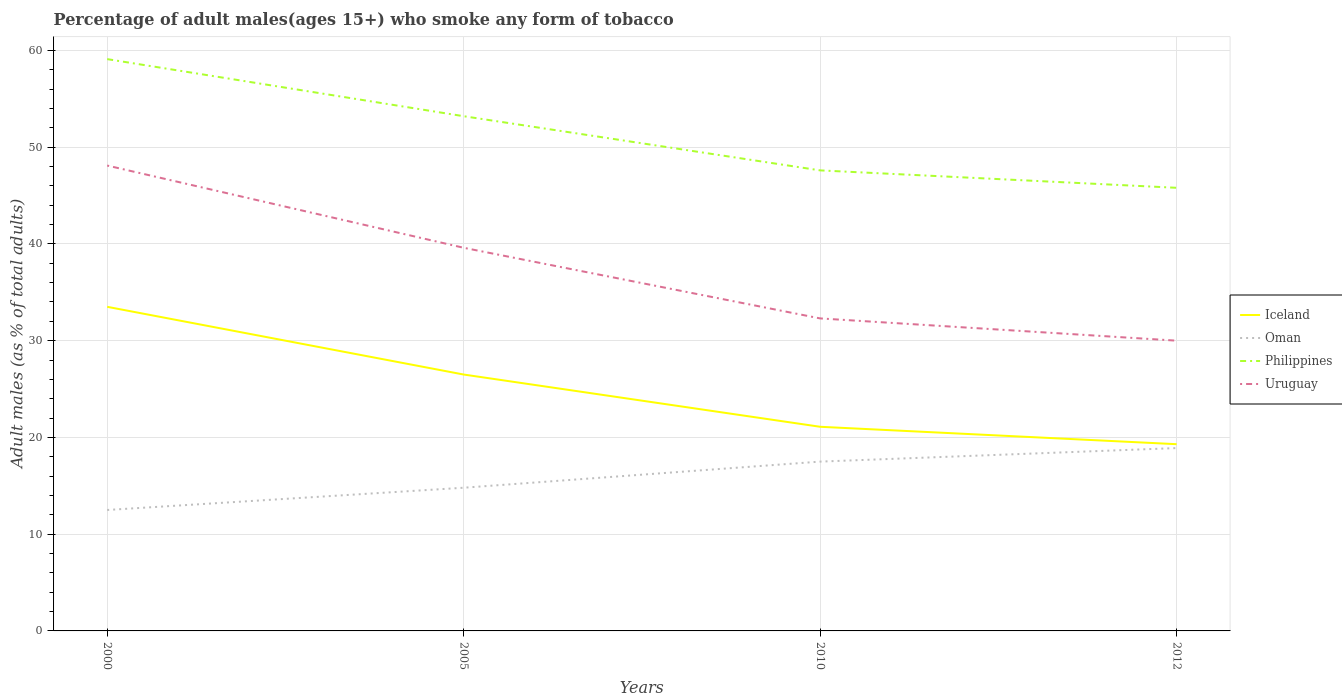How many different coloured lines are there?
Offer a very short reply. 4. Does the line corresponding to Philippines intersect with the line corresponding to Iceland?
Give a very brief answer. No. Is the number of lines equal to the number of legend labels?
Provide a short and direct response. Yes. Across all years, what is the maximum percentage of adult males who smoke in Iceland?
Offer a very short reply. 19.3. In which year was the percentage of adult males who smoke in Iceland maximum?
Offer a very short reply. 2012. What is the total percentage of adult males who smoke in Oman in the graph?
Provide a short and direct response. -5. What is the difference between the highest and the lowest percentage of adult males who smoke in Philippines?
Keep it short and to the point. 2. Is the percentage of adult males who smoke in Uruguay strictly greater than the percentage of adult males who smoke in Philippines over the years?
Your answer should be very brief. Yes. Does the graph contain any zero values?
Offer a very short reply. No. Where does the legend appear in the graph?
Your response must be concise. Center right. How many legend labels are there?
Your response must be concise. 4. How are the legend labels stacked?
Offer a terse response. Vertical. What is the title of the graph?
Give a very brief answer. Percentage of adult males(ages 15+) who smoke any form of tobacco. What is the label or title of the X-axis?
Provide a short and direct response. Years. What is the label or title of the Y-axis?
Keep it short and to the point. Adult males (as % of total adults). What is the Adult males (as % of total adults) of Iceland in 2000?
Your answer should be compact. 33.5. What is the Adult males (as % of total adults) in Philippines in 2000?
Provide a short and direct response. 59.1. What is the Adult males (as % of total adults) in Uruguay in 2000?
Give a very brief answer. 48.1. What is the Adult males (as % of total adults) of Iceland in 2005?
Provide a succinct answer. 26.5. What is the Adult males (as % of total adults) of Oman in 2005?
Your answer should be compact. 14.8. What is the Adult males (as % of total adults) in Philippines in 2005?
Give a very brief answer. 53.2. What is the Adult males (as % of total adults) in Uruguay in 2005?
Your answer should be very brief. 39.6. What is the Adult males (as % of total adults) in Iceland in 2010?
Offer a terse response. 21.1. What is the Adult males (as % of total adults) of Philippines in 2010?
Make the answer very short. 47.6. What is the Adult males (as % of total adults) of Uruguay in 2010?
Offer a terse response. 32.3. What is the Adult males (as % of total adults) of Iceland in 2012?
Provide a succinct answer. 19.3. What is the Adult males (as % of total adults) of Oman in 2012?
Your response must be concise. 18.9. What is the Adult males (as % of total adults) of Philippines in 2012?
Your answer should be compact. 45.8. Across all years, what is the maximum Adult males (as % of total adults) of Iceland?
Your answer should be very brief. 33.5. Across all years, what is the maximum Adult males (as % of total adults) of Oman?
Offer a very short reply. 18.9. Across all years, what is the maximum Adult males (as % of total adults) of Philippines?
Your response must be concise. 59.1. Across all years, what is the maximum Adult males (as % of total adults) in Uruguay?
Your answer should be very brief. 48.1. Across all years, what is the minimum Adult males (as % of total adults) of Iceland?
Your answer should be very brief. 19.3. Across all years, what is the minimum Adult males (as % of total adults) in Philippines?
Your answer should be compact. 45.8. What is the total Adult males (as % of total adults) in Iceland in the graph?
Your answer should be very brief. 100.4. What is the total Adult males (as % of total adults) in Oman in the graph?
Make the answer very short. 63.7. What is the total Adult males (as % of total adults) of Philippines in the graph?
Provide a short and direct response. 205.7. What is the total Adult males (as % of total adults) in Uruguay in the graph?
Provide a succinct answer. 150. What is the difference between the Adult males (as % of total adults) in Iceland in 2000 and that in 2005?
Your response must be concise. 7. What is the difference between the Adult males (as % of total adults) in Philippines in 2000 and that in 2005?
Ensure brevity in your answer.  5.9. What is the difference between the Adult males (as % of total adults) in Uruguay in 2000 and that in 2005?
Give a very brief answer. 8.5. What is the difference between the Adult males (as % of total adults) in Iceland in 2000 and that in 2010?
Your answer should be compact. 12.4. What is the difference between the Adult males (as % of total adults) of Philippines in 2000 and that in 2010?
Make the answer very short. 11.5. What is the difference between the Adult males (as % of total adults) of Oman in 2000 and that in 2012?
Provide a short and direct response. -6.4. What is the difference between the Adult males (as % of total adults) in Iceland in 2005 and that in 2010?
Keep it short and to the point. 5.4. What is the difference between the Adult males (as % of total adults) of Uruguay in 2005 and that in 2010?
Your answer should be very brief. 7.3. What is the difference between the Adult males (as % of total adults) in Philippines in 2005 and that in 2012?
Your answer should be compact. 7.4. What is the difference between the Adult males (as % of total adults) in Iceland in 2010 and that in 2012?
Provide a short and direct response. 1.8. What is the difference between the Adult males (as % of total adults) of Iceland in 2000 and the Adult males (as % of total adults) of Philippines in 2005?
Provide a short and direct response. -19.7. What is the difference between the Adult males (as % of total adults) in Iceland in 2000 and the Adult males (as % of total adults) in Uruguay in 2005?
Provide a succinct answer. -6.1. What is the difference between the Adult males (as % of total adults) of Oman in 2000 and the Adult males (as % of total adults) of Philippines in 2005?
Provide a short and direct response. -40.7. What is the difference between the Adult males (as % of total adults) in Oman in 2000 and the Adult males (as % of total adults) in Uruguay in 2005?
Provide a short and direct response. -27.1. What is the difference between the Adult males (as % of total adults) in Philippines in 2000 and the Adult males (as % of total adults) in Uruguay in 2005?
Provide a short and direct response. 19.5. What is the difference between the Adult males (as % of total adults) in Iceland in 2000 and the Adult males (as % of total adults) in Philippines in 2010?
Provide a succinct answer. -14.1. What is the difference between the Adult males (as % of total adults) in Oman in 2000 and the Adult males (as % of total adults) in Philippines in 2010?
Provide a short and direct response. -35.1. What is the difference between the Adult males (as % of total adults) of Oman in 2000 and the Adult males (as % of total adults) of Uruguay in 2010?
Your answer should be very brief. -19.8. What is the difference between the Adult males (as % of total adults) of Philippines in 2000 and the Adult males (as % of total adults) of Uruguay in 2010?
Keep it short and to the point. 26.8. What is the difference between the Adult males (as % of total adults) in Iceland in 2000 and the Adult males (as % of total adults) in Oman in 2012?
Make the answer very short. 14.6. What is the difference between the Adult males (as % of total adults) of Iceland in 2000 and the Adult males (as % of total adults) of Philippines in 2012?
Offer a very short reply. -12.3. What is the difference between the Adult males (as % of total adults) in Oman in 2000 and the Adult males (as % of total adults) in Philippines in 2012?
Your answer should be compact. -33.3. What is the difference between the Adult males (as % of total adults) of Oman in 2000 and the Adult males (as % of total adults) of Uruguay in 2012?
Make the answer very short. -17.5. What is the difference between the Adult males (as % of total adults) of Philippines in 2000 and the Adult males (as % of total adults) of Uruguay in 2012?
Offer a very short reply. 29.1. What is the difference between the Adult males (as % of total adults) in Iceland in 2005 and the Adult males (as % of total adults) in Oman in 2010?
Your response must be concise. 9. What is the difference between the Adult males (as % of total adults) of Iceland in 2005 and the Adult males (as % of total adults) of Philippines in 2010?
Offer a terse response. -21.1. What is the difference between the Adult males (as % of total adults) of Oman in 2005 and the Adult males (as % of total adults) of Philippines in 2010?
Make the answer very short. -32.8. What is the difference between the Adult males (as % of total adults) of Oman in 2005 and the Adult males (as % of total adults) of Uruguay in 2010?
Give a very brief answer. -17.5. What is the difference between the Adult males (as % of total adults) of Philippines in 2005 and the Adult males (as % of total adults) of Uruguay in 2010?
Offer a terse response. 20.9. What is the difference between the Adult males (as % of total adults) of Iceland in 2005 and the Adult males (as % of total adults) of Oman in 2012?
Give a very brief answer. 7.6. What is the difference between the Adult males (as % of total adults) of Iceland in 2005 and the Adult males (as % of total adults) of Philippines in 2012?
Provide a short and direct response. -19.3. What is the difference between the Adult males (as % of total adults) of Oman in 2005 and the Adult males (as % of total adults) of Philippines in 2012?
Provide a succinct answer. -31. What is the difference between the Adult males (as % of total adults) of Oman in 2005 and the Adult males (as % of total adults) of Uruguay in 2012?
Keep it short and to the point. -15.2. What is the difference between the Adult males (as % of total adults) of Philippines in 2005 and the Adult males (as % of total adults) of Uruguay in 2012?
Ensure brevity in your answer.  23.2. What is the difference between the Adult males (as % of total adults) in Iceland in 2010 and the Adult males (as % of total adults) in Philippines in 2012?
Provide a short and direct response. -24.7. What is the difference between the Adult males (as % of total adults) of Iceland in 2010 and the Adult males (as % of total adults) of Uruguay in 2012?
Make the answer very short. -8.9. What is the difference between the Adult males (as % of total adults) of Oman in 2010 and the Adult males (as % of total adults) of Philippines in 2012?
Your answer should be very brief. -28.3. What is the average Adult males (as % of total adults) of Iceland per year?
Provide a succinct answer. 25.1. What is the average Adult males (as % of total adults) of Oman per year?
Give a very brief answer. 15.93. What is the average Adult males (as % of total adults) of Philippines per year?
Provide a succinct answer. 51.42. What is the average Adult males (as % of total adults) of Uruguay per year?
Keep it short and to the point. 37.5. In the year 2000, what is the difference between the Adult males (as % of total adults) of Iceland and Adult males (as % of total adults) of Philippines?
Ensure brevity in your answer.  -25.6. In the year 2000, what is the difference between the Adult males (as % of total adults) of Iceland and Adult males (as % of total adults) of Uruguay?
Make the answer very short. -14.6. In the year 2000, what is the difference between the Adult males (as % of total adults) of Oman and Adult males (as % of total adults) of Philippines?
Your answer should be very brief. -46.6. In the year 2000, what is the difference between the Adult males (as % of total adults) of Oman and Adult males (as % of total adults) of Uruguay?
Offer a very short reply. -35.6. In the year 2000, what is the difference between the Adult males (as % of total adults) in Philippines and Adult males (as % of total adults) in Uruguay?
Your response must be concise. 11. In the year 2005, what is the difference between the Adult males (as % of total adults) in Iceland and Adult males (as % of total adults) in Oman?
Make the answer very short. 11.7. In the year 2005, what is the difference between the Adult males (as % of total adults) of Iceland and Adult males (as % of total adults) of Philippines?
Your answer should be compact. -26.7. In the year 2005, what is the difference between the Adult males (as % of total adults) of Oman and Adult males (as % of total adults) of Philippines?
Offer a very short reply. -38.4. In the year 2005, what is the difference between the Adult males (as % of total adults) in Oman and Adult males (as % of total adults) in Uruguay?
Make the answer very short. -24.8. In the year 2010, what is the difference between the Adult males (as % of total adults) in Iceland and Adult males (as % of total adults) in Philippines?
Offer a terse response. -26.5. In the year 2010, what is the difference between the Adult males (as % of total adults) of Iceland and Adult males (as % of total adults) of Uruguay?
Your answer should be very brief. -11.2. In the year 2010, what is the difference between the Adult males (as % of total adults) of Oman and Adult males (as % of total adults) of Philippines?
Keep it short and to the point. -30.1. In the year 2010, what is the difference between the Adult males (as % of total adults) of Oman and Adult males (as % of total adults) of Uruguay?
Provide a succinct answer. -14.8. In the year 2012, what is the difference between the Adult males (as % of total adults) of Iceland and Adult males (as % of total adults) of Philippines?
Give a very brief answer. -26.5. In the year 2012, what is the difference between the Adult males (as % of total adults) in Iceland and Adult males (as % of total adults) in Uruguay?
Provide a short and direct response. -10.7. In the year 2012, what is the difference between the Adult males (as % of total adults) in Oman and Adult males (as % of total adults) in Philippines?
Offer a very short reply. -26.9. In the year 2012, what is the difference between the Adult males (as % of total adults) of Oman and Adult males (as % of total adults) of Uruguay?
Offer a very short reply. -11.1. What is the ratio of the Adult males (as % of total adults) of Iceland in 2000 to that in 2005?
Your answer should be compact. 1.26. What is the ratio of the Adult males (as % of total adults) in Oman in 2000 to that in 2005?
Your answer should be very brief. 0.84. What is the ratio of the Adult males (as % of total adults) in Philippines in 2000 to that in 2005?
Offer a very short reply. 1.11. What is the ratio of the Adult males (as % of total adults) of Uruguay in 2000 to that in 2005?
Offer a very short reply. 1.21. What is the ratio of the Adult males (as % of total adults) of Iceland in 2000 to that in 2010?
Make the answer very short. 1.59. What is the ratio of the Adult males (as % of total adults) in Philippines in 2000 to that in 2010?
Your answer should be compact. 1.24. What is the ratio of the Adult males (as % of total adults) of Uruguay in 2000 to that in 2010?
Ensure brevity in your answer.  1.49. What is the ratio of the Adult males (as % of total adults) in Iceland in 2000 to that in 2012?
Your response must be concise. 1.74. What is the ratio of the Adult males (as % of total adults) in Oman in 2000 to that in 2012?
Offer a terse response. 0.66. What is the ratio of the Adult males (as % of total adults) in Philippines in 2000 to that in 2012?
Ensure brevity in your answer.  1.29. What is the ratio of the Adult males (as % of total adults) of Uruguay in 2000 to that in 2012?
Your answer should be very brief. 1.6. What is the ratio of the Adult males (as % of total adults) in Iceland in 2005 to that in 2010?
Make the answer very short. 1.26. What is the ratio of the Adult males (as % of total adults) of Oman in 2005 to that in 2010?
Provide a short and direct response. 0.85. What is the ratio of the Adult males (as % of total adults) of Philippines in 2005 to that in 2010?
Provide a succinct answer. 1.12. What is the ratio of the Adult males (as % of total adults) in Uruguay in 2005 to that in 2010?
Give a very brief answer. 1.23. What is the ratio of the Adult males (as % of total adults) of Iceland in 2005 to that in 2012?
Provide a short and direct response. 1.37. What is the ratio of the Adult males (as % of total adults) of Oman in 2005 to that in 2012?
Offer a terse response. 0.78. What is the ratio of the Adult males (as % of total adults) of Philippines in 2005 to that in 2012?
Keep it short and to the point. 1.16. What is the ratio of the Adult males (as % of total adults) of Uruguay in 2005 to that in 2012?
Your answer should be compact. 1.32. What is the ratio of the Adult males (as % of total adults) of Iceland in 2010 to that in 2012?
Give a very brief answer. 1.09. What is the ratio of the Adult males (as % of total adults) in Oman in 2010 to that in 2012?
Make the answer very short. 0.93. What is the ratio of the Adult males (as % of total adults) of Philippines in 2010 to that in 2012?
Offer a terse response. 1.04. What is the ratio of the Adult males (as % of total adults) of Uruguay in 2010 to that in 2012?
Provide a short and direct response. 1.08. What is the difference between the highest and the lowest Adult males (as % of total adults) of Iceland?
Provide a succinct answer. 14.2. What is the difference between the highest and the lowest Adult males (as % of total adults) of Uruguay?
Make the answer very short. 18.1. 